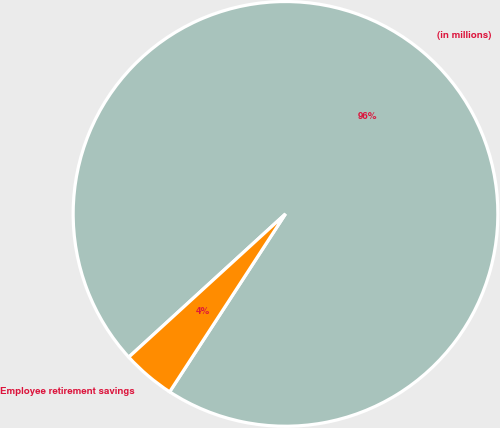Convert chart. <chart><loc_0><loc_0><loc_500><loc_500><pie_chart><fcel>(in millions)<fcel>Employee retirement savings<nl><fcel>95.97%<fcel>4.03%<nl></chart> 